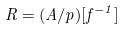<formula> <loc_0><loc_0><loc_500><loc_500>R = ( A / p ) [ f ^ { - 1 } ]</formula> 